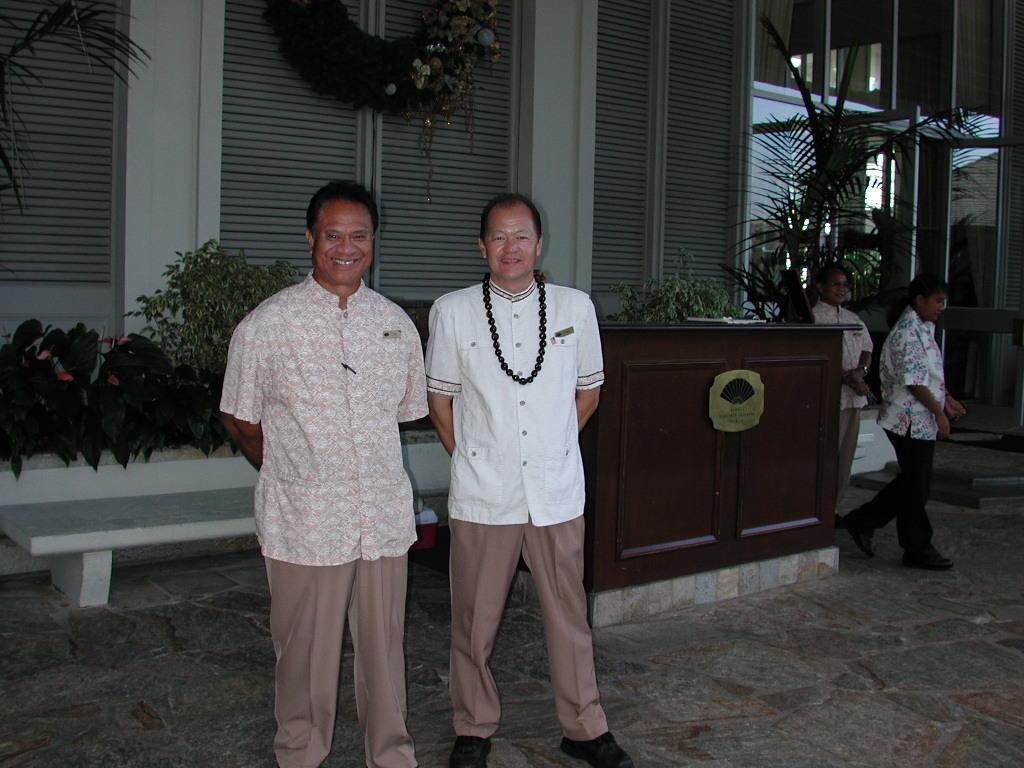Can you describe this image briefly? In this image, we can see two men are standing, watching and smiling. Background we can see few plants, desk, bench, wall, trees, decorative piece, glass doors. On the right side of the image, we can see two people. Here a person is walking and holding an object. 